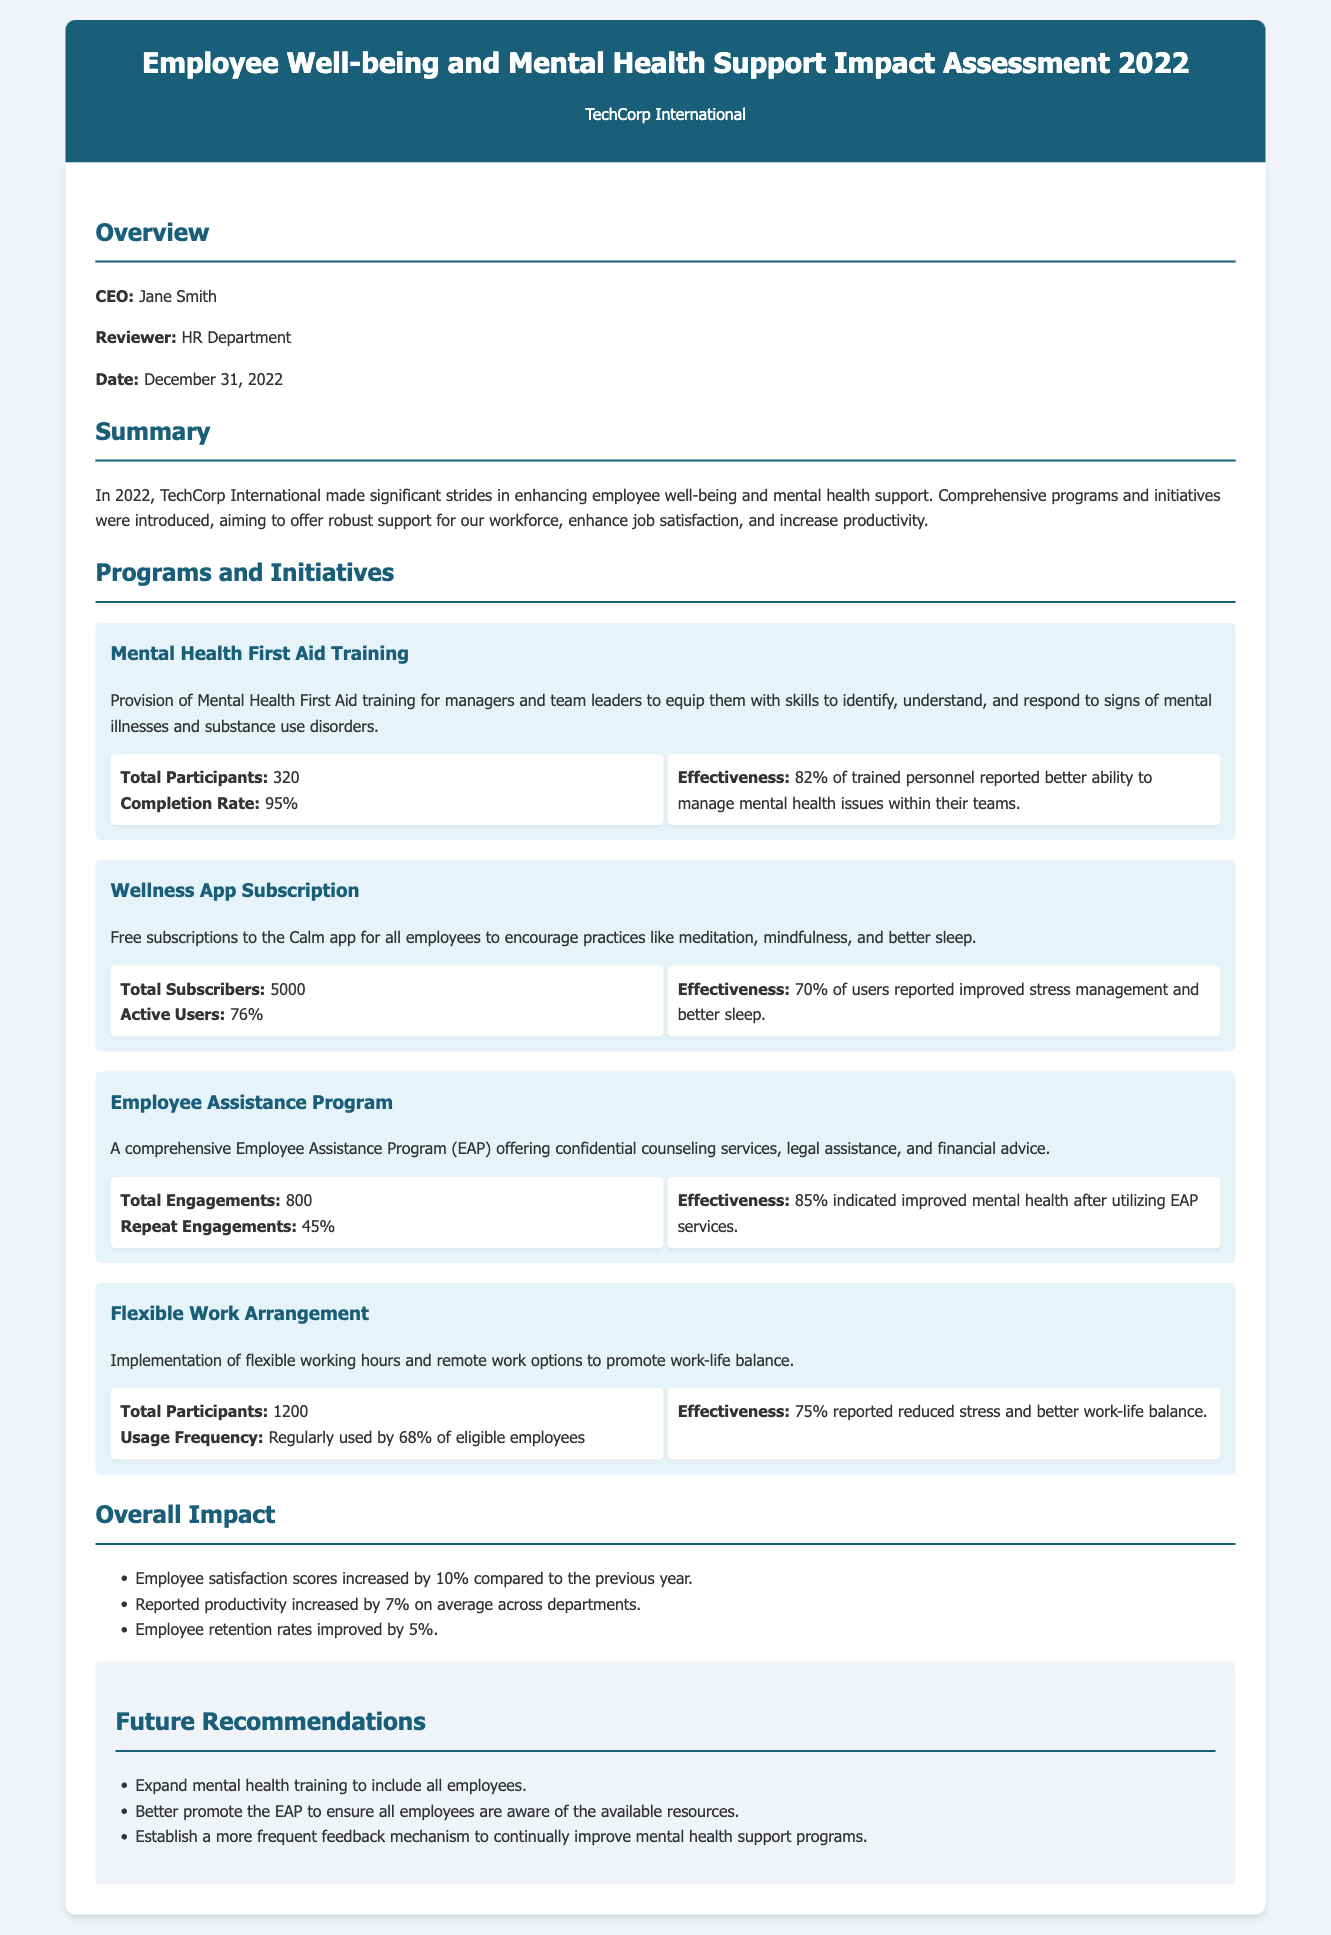what was the completion rate for Mental Health First Aid Training? The completion rate is listed under the Mental Health First Aid Training program, which is 95%.
Answer: 95% how many employees participated in the Flexible Work Arrangement? The total participants for the Flexible Work Arrangement program is mentioned as 1200.
Answer: 1200 what percentage of Active Users reported improved stress management using the Wellness App? The effectiveness of the Wellness App Subscription program indicates that 70% of users reported improved stress management.
Answer: 70% what is the total number of engagements for the Employee Assistance Program? The document states that there were 800 total engagements for the Employee Assistance Program.
Answer: 800 which program had the highest reported effectiveness? The effectiveness report indicates that 85% of users indicated improved mental health after utilizing the Employee Assistance Program, which is the highest among the listed programs.
Answer: Employee Assistance Program how much did employee satisfaction scores increase compared to the previous year? The document states that employee satisfaction scores increased by 10% compared to the previous year.
Answer: 10% what was the overall reported productivity increase across departments? The report mentions that the reported productivity increased by 7% on average across departments.
Answer: 7% what are the future recommendations mentioned in the document? The document includes recommendations such as expanding mental health training, promoting the EAP, and establishing a feedback mechanism.
Answer: Expand mental health training, promote EAP, establish feedback mechanism what was the total number of participants in Mental Health First Aid Training? The total participants is stated as 320 under the Mental Health First Aid Training program.
Answer: 320 